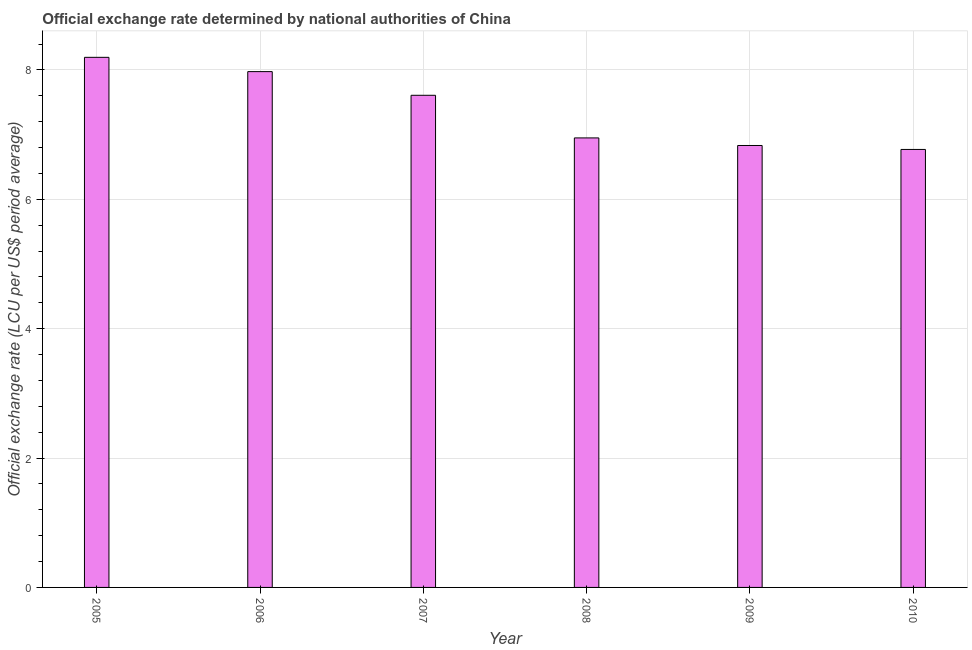Does the graph contain grids?
Provide a succinct answer. Yes. What is the title of the graph?
Keep it short and to the point. Official exchange rate determined by national authorities of China. What is the label or title of the Y-axis?
Offer a very short reply. Official exchange rate (LCU per US$ period average). What is the official exchange rate in 2009?
Give a very brief answer. 6.83. Across all years, what is the maximum official exchange rate?
Your answer should be very brief. 8.19. Across all years, what is the minimum official exchange rate?
Offer a very short reply. 6.77. In which year was the official exchange rate minimum?
Provide a short and direct response. 2010. What is the sum of the official exchange rate?
Offer a terse response. 44.33. What is the difference between the official exchange rate in 2006 and 2009?
Give a very brief answer. 1.14. What is the average official exchange rate per year?
Your response must be concise. 7.39. What is the median official exchange rate?
Provide a succinct answer. 7.28. What is the ratio of the official exchange rate in 2006 to that in 2008?
Your answer should be compact. 1.15. Is the official exchange rate in 2007 less than that in 2008?
Give a very brief answer. No. What is the difference between the highest and the second highest official exchange rate?
Give a very brief answer. 0.22. Is the sum of the official exchange rate in 2007 and 2009 greater than the maximum official exchange rate across all years?
Provide a short and direct response. Yes. What is the difference between the highest and the lowest official exchange rate?
Provide a succinct answer. 1.42. How many bars are there?
Your answer should be very brief. 6. Are all the bars in the graph horizontal?
Your answer should be compact. No. How many years are there in the graph?
Offer a very short reply. 6. Are the values on the major ticks of Y-axis written in scientific E-notation?
Make the answer very short. No. What is the Official exchange rate (LCU per US$ period average) of 2005?
Keep it short and to the point. 8.19. What is the Official exchange rate (LCU per US$ period average) in 2006?
Give a very brief answer. 7.97. What is the Official exchange rate (LCU per US$ period average) in 2007?
Your answer should be very brief. 7.61. What is the Official exchange rate (LCU per US$ period average) in 2008?
Provide a succinct answer. 6.95. What is the Official exchange rate (LCU per US$ period average) of 2009?
Provide a short and direct response. 6.83. What is the Official exchange rate (LCU per US$ period average) of 2010?
Your answer should be compact. 6.77. What is the difference between the Official exchange rate (LCU per US$ period average) in 2005 and 2006?
Offer a very short reply. 0.22. What is the difference between the Official exchange rate (LCU per US$ period average) in 2005 and 2007?
Your answer should be compact. 0.59. What is the difference between the Official exchange rate (LCU per US$ period average) in 2005 and 2008?
Give a very brief answer. 1.25. What is the difference between the Official exchange rate (LCU per US$ period average) in 2005 and 2009?
Offer a terse response. 1.36. What is the difference between the Official exchange rate (LCU per US$ period average) in 2005 and 2010?
Provide a succinct answer. 1.42. What is the difference between the Official exchange rate (LCU per US$ period average) in 2006 and 2007?
Offer a terse response. 0.37. What is the difference between the Official exchange rate (LCU per US$ period average) in 2006 and 2008?
Offer a very short reply. 1.02. What is the difference between the Official exchange rate (LCU per US$ period average) in 2006 and 2009?
Keep it short and to the point. 1.14. What is the difference between the Official exchange rate (LCU per US$ period average) in 2006 and 2010?
Offer a very short reply. 1.2. What is the difference between the Official exchange rate (LCU per US$ period average) in 2007 and 2008?
Your answer should be very brief. 0.66. What is the difference between the Official exchange rate (LCU per US$ period average) in 2007 and 2009?
Offer a very short reply. 0.78. What is the difference between the Official exchange rate (LCU per US$ period average) in 2007 and 2010?
Provide a short and direct response. 0.84. What is the difference between the Official exchange rate (LCU per US$ period average) in 2008 and 2009?
Ensure brevity in your answer.  0.12. What is the difference between the Official exchange rate (LCU per US$ period average) in 2008 and 2010?
Your answer should be compact. 0.18. What is the difference between the Official exchange rate (LCU per US$ period average) in 2009 and 2010?
Ensure brevity in your answer.  0.06. What is the ratio of the Official exchange rate (LCU per US$ period average) in 2005 to that in 2006?
Your answer should be compact. 1.03. What is the ratio of the Official exchange rate (LCU per US$ period average) in 2005 to that in 2007?
Provide a short and direct response. 1.08. What is the ratio of the Official exchange rate (LCU per US$ period average) in 2005 to that in 2008?
Provide a succinct answer. 1.18. What is the ratio of the Official exchange rate (LCU per US$ period average) in 2005 to that in 2010?
Give a very brief answer. 1.21. What is the ratio of the Official exchange rate (LCU per US$ period average) in 2006 to that in 2007?
Your answer should be very brief. 1.05. What is the ratio of the Official exchange rate (LCU per US$ period average) in 2006 to that in 2008?
Provide a succinct answer. 1.15. What is the ratio of the Official exchange rate (LCU per US$ period average) in 2006 to that in 2009?
Ensure brevity in your answer.  1.17. What is the ratio of the Official exchange rate (LCU per US$ period average) in 2006 to that in 2010?
Provide a short and direct response. 1.18. What is the ratio of the Official exchange rate (LCU per US$ period average) in 2007 to that in 2008?
Keep it short and to the point. 1.09. What is the ratio of the Official exchange rate (LCU per US$ period average) in 2007 to that in 2009?
Offer a very short reply. 1.11. What is the ratio of the Official exchange rate (LCU per US$ period average) in 2007 to that in 2010?
Give a very brief answer. 1.12. 